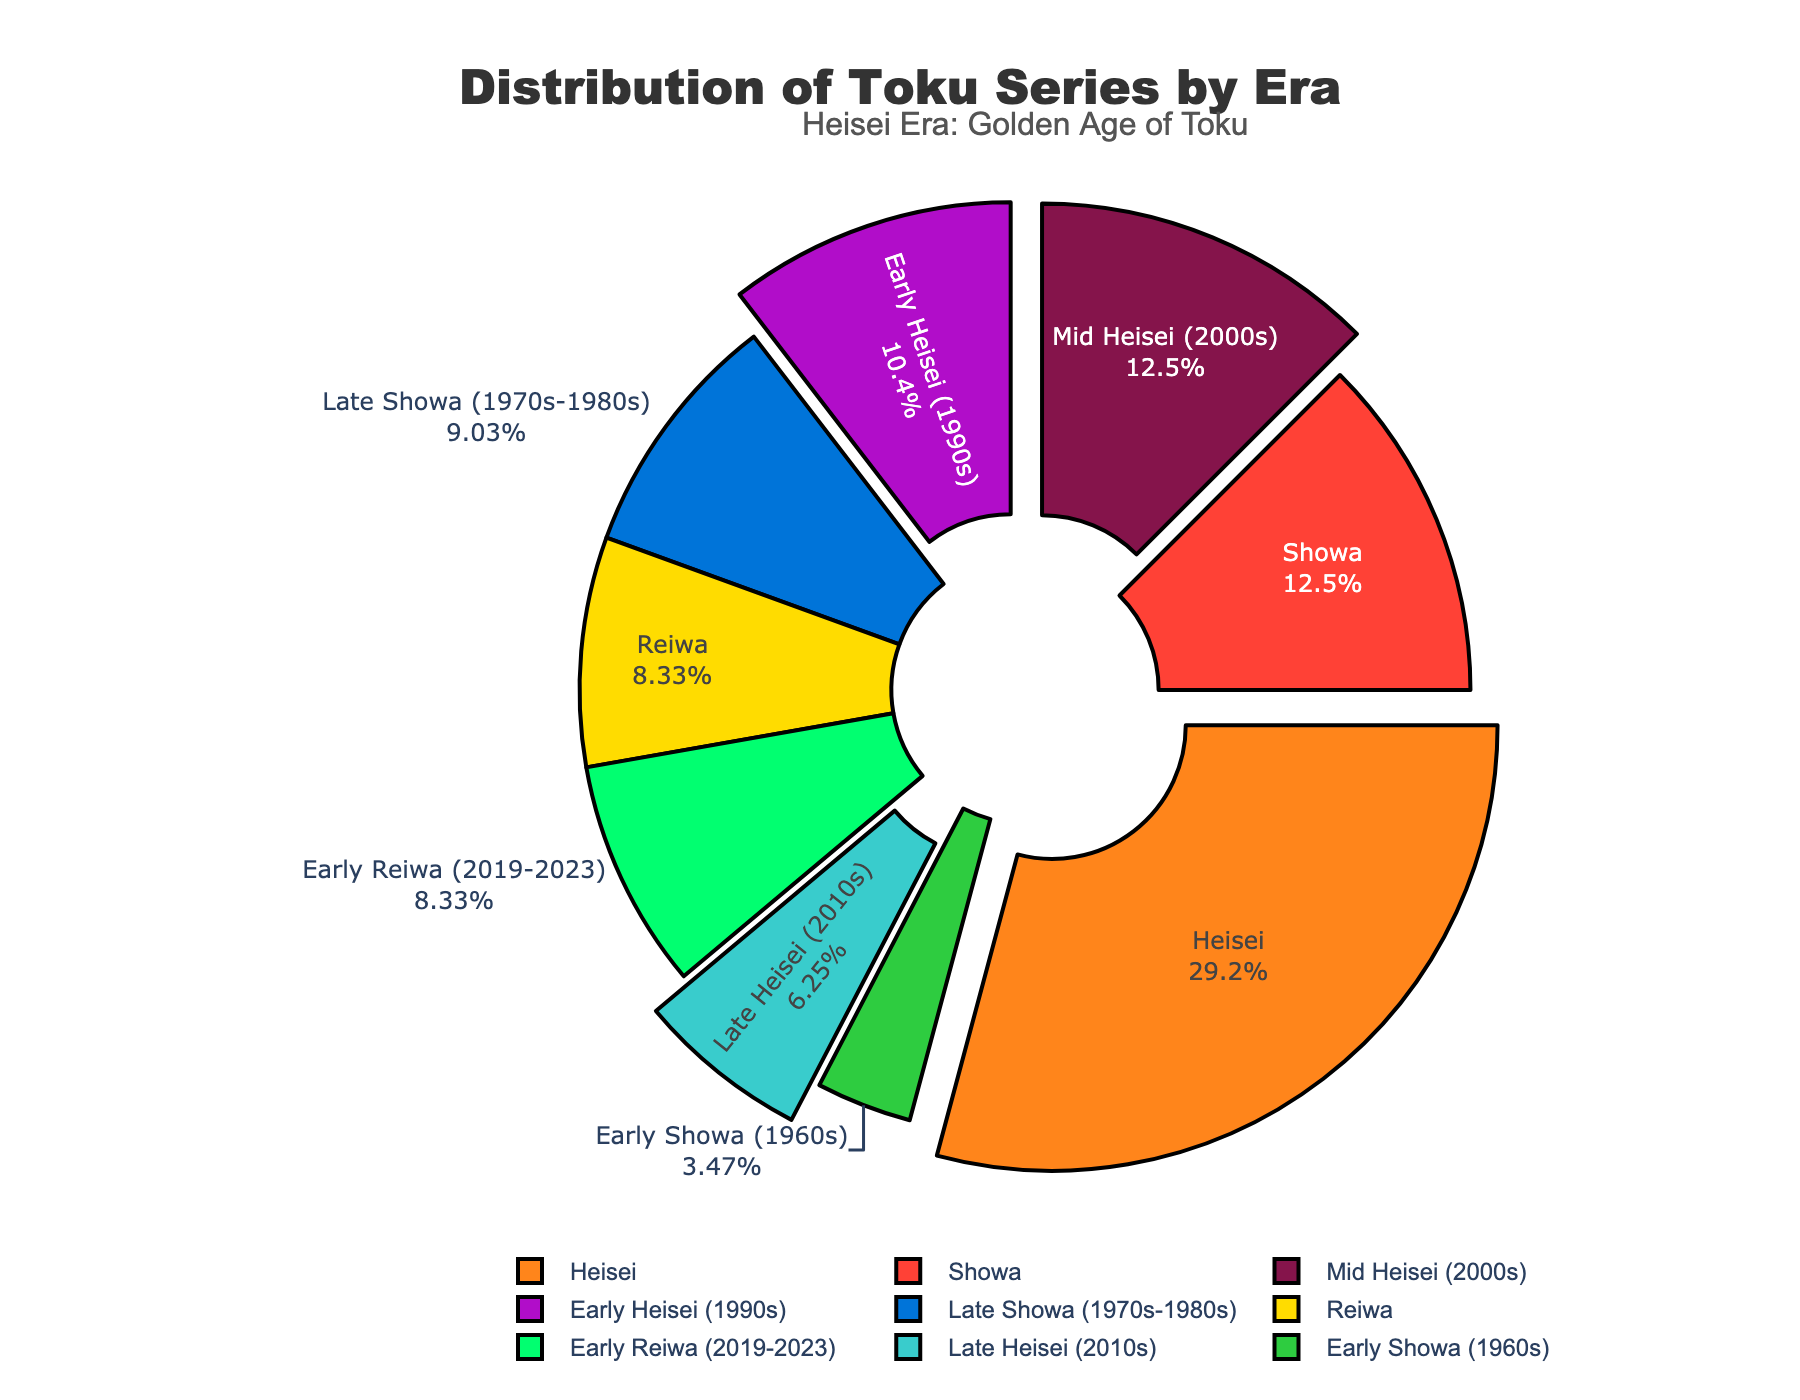Which era has the highest number of Toku series? Looking at the pie chart, the segment with the largest proportion represents the era with the highest number of series. The Heisei era covers the largest portion.
Answer: Heisei How many more series were produced in the Heisei era compared to the Showa era? First, identify the number of series in the Heisei era (42) and the Showa era (18). Subtract the number of Showa series from the Heisei series: 42 - 18.
Answer: 24 What percentage of Toku series were released during the Early Heisei period? The Early Heisei period comprises 15 series out of the total (18+42+12) = 72 series. Calculate the percentage: (15 / 72) * 100.
Answer: 20.83% Which era's section is highlighted or pulled out in the chart? The chart annotation and visual distinction (pull) make it immediately noticeable. The Heisei era section is pulled out to highlight it.
Answer: Heisei Were there more Toku series produced in the Late Showa period or Early Heisei period? Compare the number of series in the Late Showa period (13) with the Early Heisei period (15). The Early Heisei period produced more series.
Answer: Early Heisei What is the ratio of Toku series produced in the Reiwa era to those in the Mid Heisei period? Identify the number of series for Reiwa (12) and Mid Heisei (18). Then, find the ratio 12:18, which can be simplified to 2:3.
Answer: 2:3 What proportion of the total number of series were produced in Showa and Heisei combined? Sum the series from Showa (18) and Heisei (42) to get 60. Then, find this as a proportion of the total (72): (60 / 72) * 100.
Answer: 83.33% How much greater is the number of series produced in Mid Heisei compared to Late Heisei? Compare the series numbers in Mid Heisei (18) and Late Heisei (9). Subtract Late Heisei from Mid Heisei: 18 - 9.
Answer: 9 What visual cue is used to designate the Heisei era in the pie chart? The pie chart uses visual highlighting (pull effect) and an annotation to draw attention to the Heisei era.
Answer: Pull effect How does the number of series in Early Reiwa compare to the total number of series in Early and Late Showa combined? Identify the number of series in Early Reiwa (12) and sum the series numbers in Early Showa (5) and Late Showa (13): 5 + 13 = 18. Compare 12 to 18.
Answer: Less 